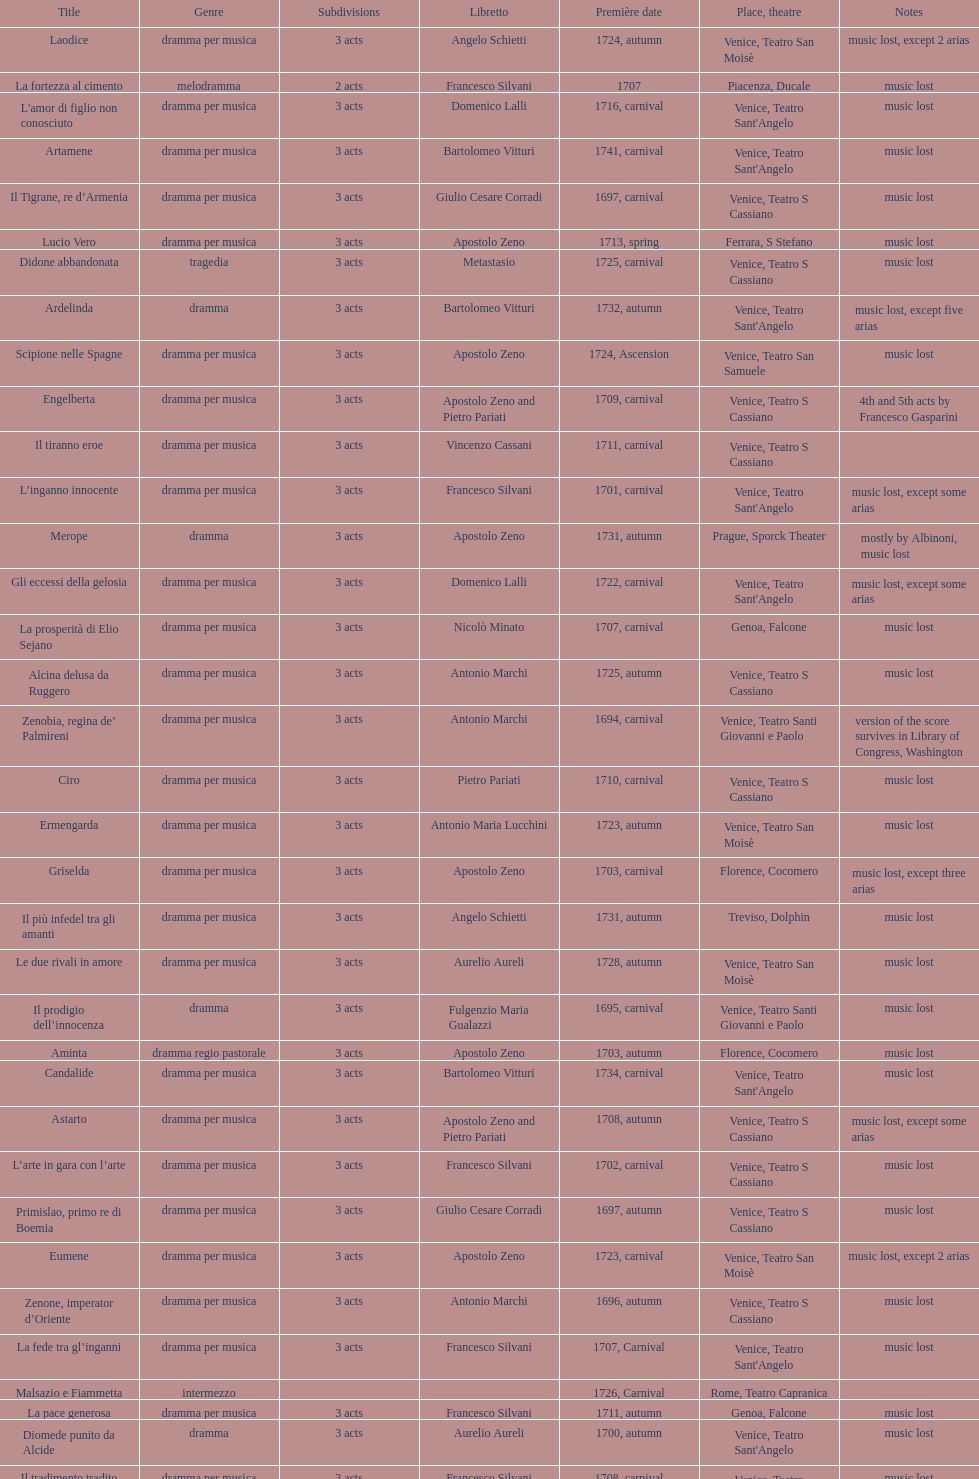How many were released after zenone, imperator d'oriente? 52. 